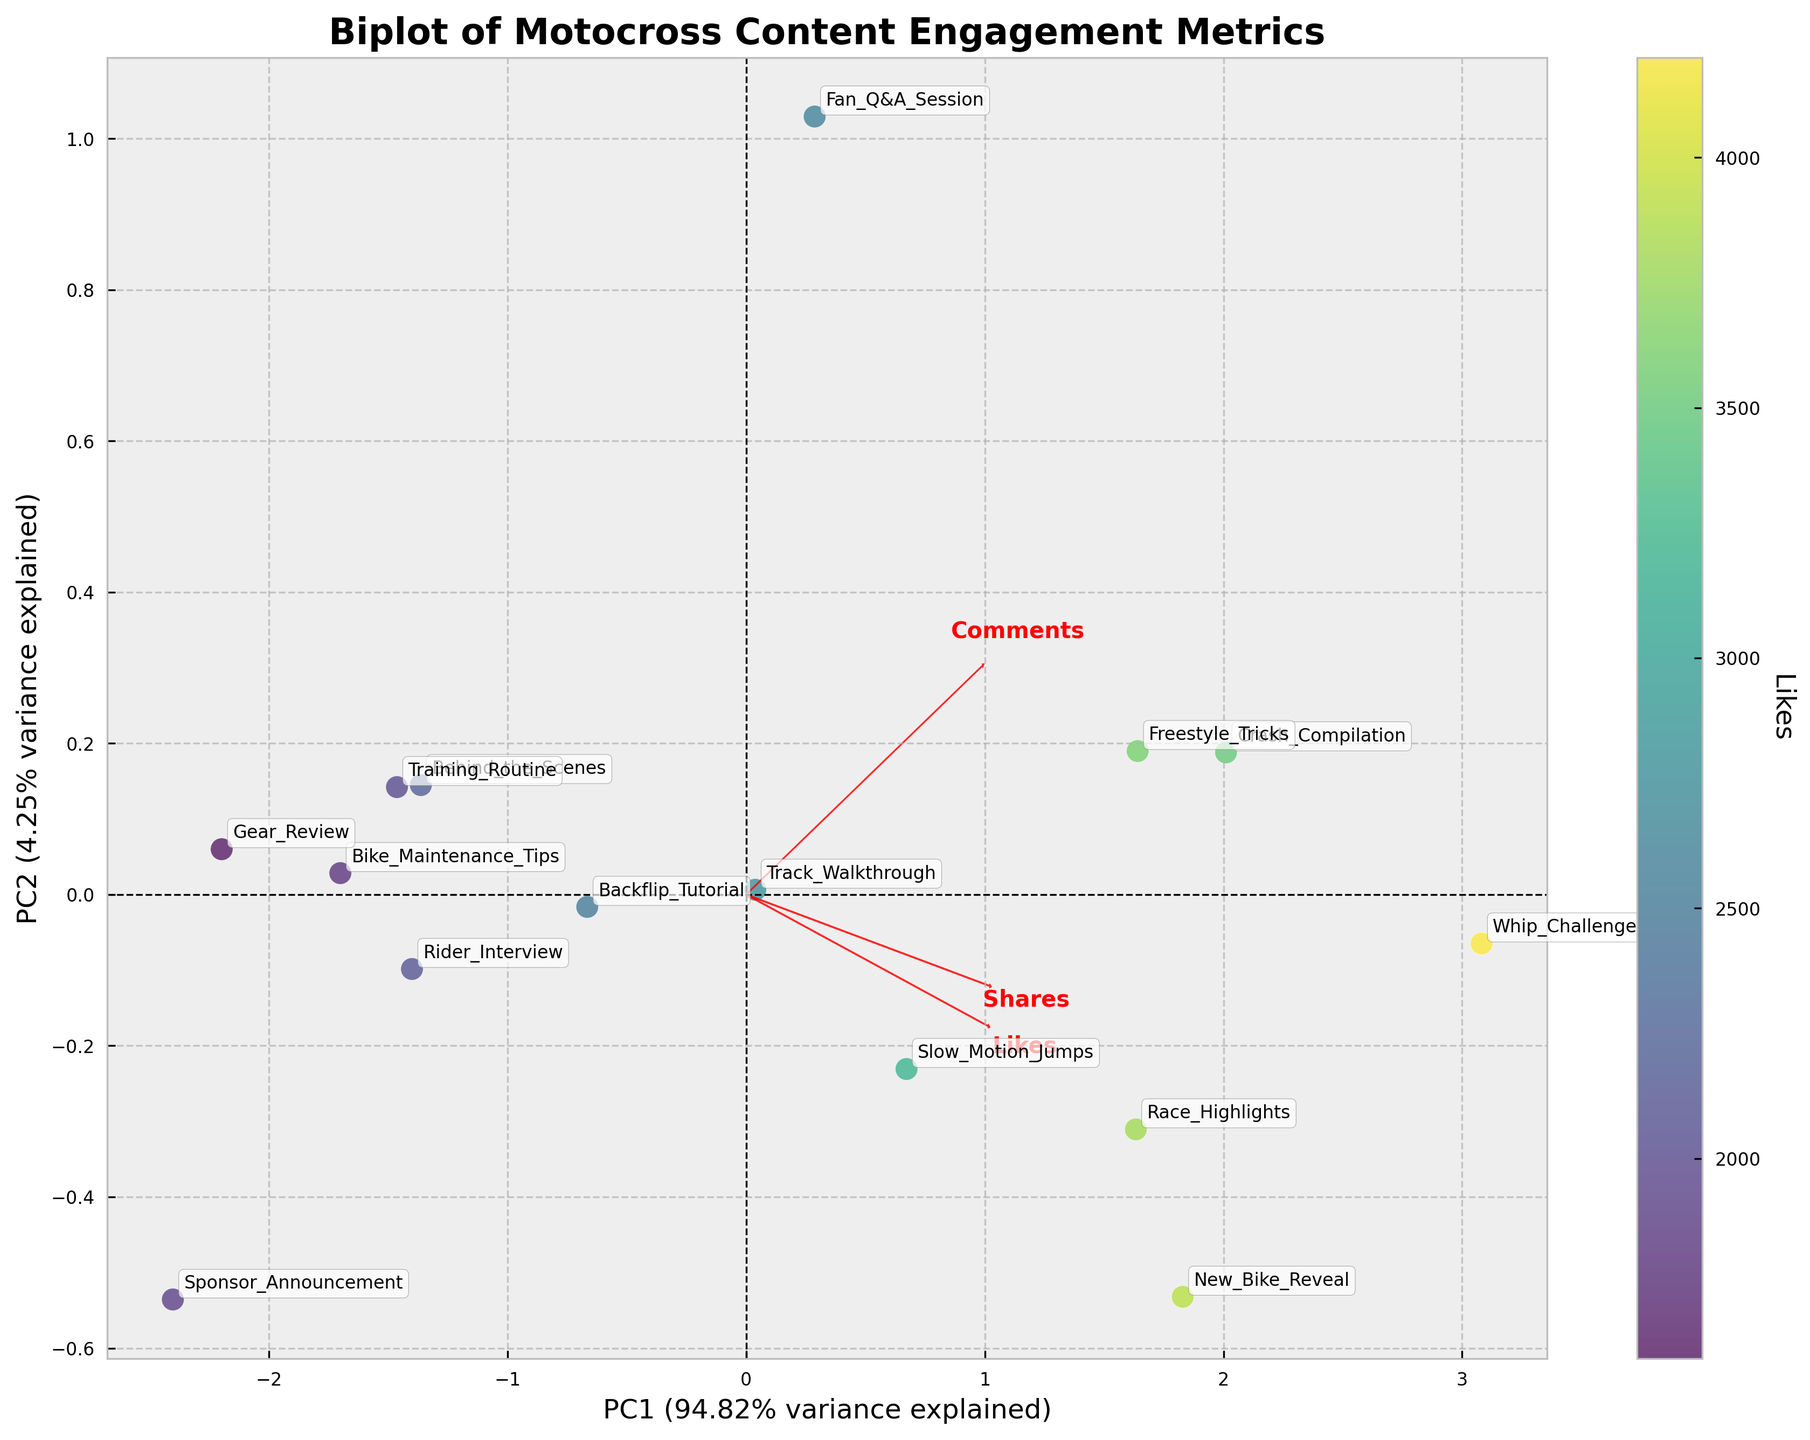What does the scatter plot visualize? The scatter plot visualizes the PCA-transformed data, where each point represents a different type of motocross content. The points are color-coded based on the number of likes. This combination allows us to see clusters and trends among the content types based on engagement metrics.
Answer: PCA-transformed data of content types, color-coded by likes What does PC1 and PC2 represent in the plot? PC1 and PC2 are the principal components that explain the most variance in the data. PC1 explains the most significant amount of variance, while PC2 explains the second most. They are linear combinations of the engagement metrics (likes, shares, comments).
Answer: Principal components Which content type seems to have the highest engagement in terms of likes? "Whip Challenge" is the content type that appears in the scatter with the brightest color, indicating the highest number of likes among all other content types.
Answer: Whip Challenge Are there any content types that are closely clustered together? Content types like "Backflip Tutorial," "Behind the Scenes," and "Bike Maintenance Tips" appear close together in the plot. This suggests that their engagement metrics are quite similar.
Answer: Backflip Tutorial, Behind the Scenes, Bike Maintenance Tips Which content type shows the highest engagement in terms of shares and comments? The "Whip Challenge" seems to have the highest engagement in terms of shares and comments as it is positioned farther in the direction of the feature vectors for Shares and Comments.
Answer: Whip Challenge How do the engagement metrics for "Crash Compilation" compare to those for "Rider Interview"? "Crash Compilation" shows higher likes, shares, and comments as it is farther along the vectors for these engagement metrics compared to "Rider Interview."
Answer: Crash Compilation has higher metrics What is the correlation between the original features and the principal components? The red arrows in the plot represent the feature vectors, which show that "Likes," "Shares," and "Comments" are positively correlated with PC1. The length and direction of these arrows indicate the strength and direction of the correlation.
Answer: Likes, Shares, and Comments are positively correlated with PC1 Which principal component explains the most variance in the data? PC1 explains the most variance in the data, as indicated by the longer axis label for PC1.
Answer: PC1 How much variance in the data is explained by PC1 and PC2 combined? The plot indicates the amount of variance explained by PC1 and PC2 in the axis labels. Summing both percentages gives the total variance explained by these two components. This information usually can be found in the axis labels as “PC1 (xx.xx% variance explained)” and “PC2 (yy.yy% variance explained).”
Answer: Sum of PC1 and PC2 variance percentages Do the "Freestyle Tricks" and "Slow Motion Jumps" content types have similar engagement patterns? "Freestyle Tricks" and "Slow Motion Jumps" are positioned close to each other, indicating that they have similar engagement patterns in terms of likes, shares, and comments.
Answer: Yes 